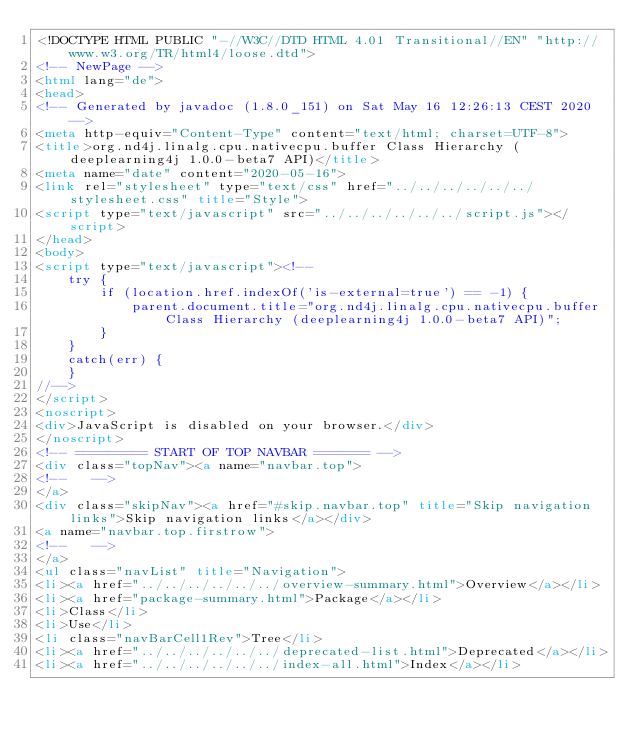<code> <loc_0><loc_0><loc_500><loc_500><_HTML_><!DOCTYPE HTML PUBLIC "-//W3C//DTD HTML 4.01 Transitional//EN" "http://www.w3.org/TR/html4/loose.dtd">
<!-- NewPage -->
<html lang="de">
<head>
<!-- Generated by javadoc (1.8.0_151) on Sat May 16 12:26:13 CEST 2020 -->
<meta http-equiv="Content-Type" content="text/html; charset=UTF-8">
<title>org.nd4j.linalg.cpu.nativecpu.buffer Class Hierarchy (deeplearning4j 1.0.0-beta7 API)</title>
<meta name="date" content="2020-05-16">
<link rel="stylesheet" type="text/css" href="../../../../../../stylesheet.css" title="Style">
<script type="text/javascript" src="../../../../../../script.js"></script>
</head>
<body>
<script type="text/javascript"><!--
    try {
        if (location.href.indexOf('is-external=true') == -1) {
            parent.document.title="org.nd4j.linalg.cpu.nativecpu.buffer Class Hierarchy (deeplearning4j 1.0.0-beta7 API)";
        }
    }
    catch(err) {
    }
//-->
</script>
<noscript>
<div>JavaScript is disabled on your browser.</div>
</noscript>
<!-- ========= START OF TOP NAVBAR ======= -->
<div class="topNav"><a name="navbar.top">
<!--   -->
</a>
<div class="skipNav"><a href="#skip.navbar.top" title="Skip navigation links">Skip navigation links</a></div>
<a name="navbar.top.firstrow">
<!--   -->
</a>
<ul class="navList" title="Navigation">
<li><a href="../../../../../../overview-summary.html">Overview</a></li>
<li><a href="package-summary.html">Package</a></li>
<li>Class</li>
<li>Use</li>
<li class="navBarCell1Rev">Tree</li>
<li><a href="../../../../../../deprecated-list.html">Deprecated</a></li>
<li><a href="../../../../../../index-all.html">Index</a></li></code> 